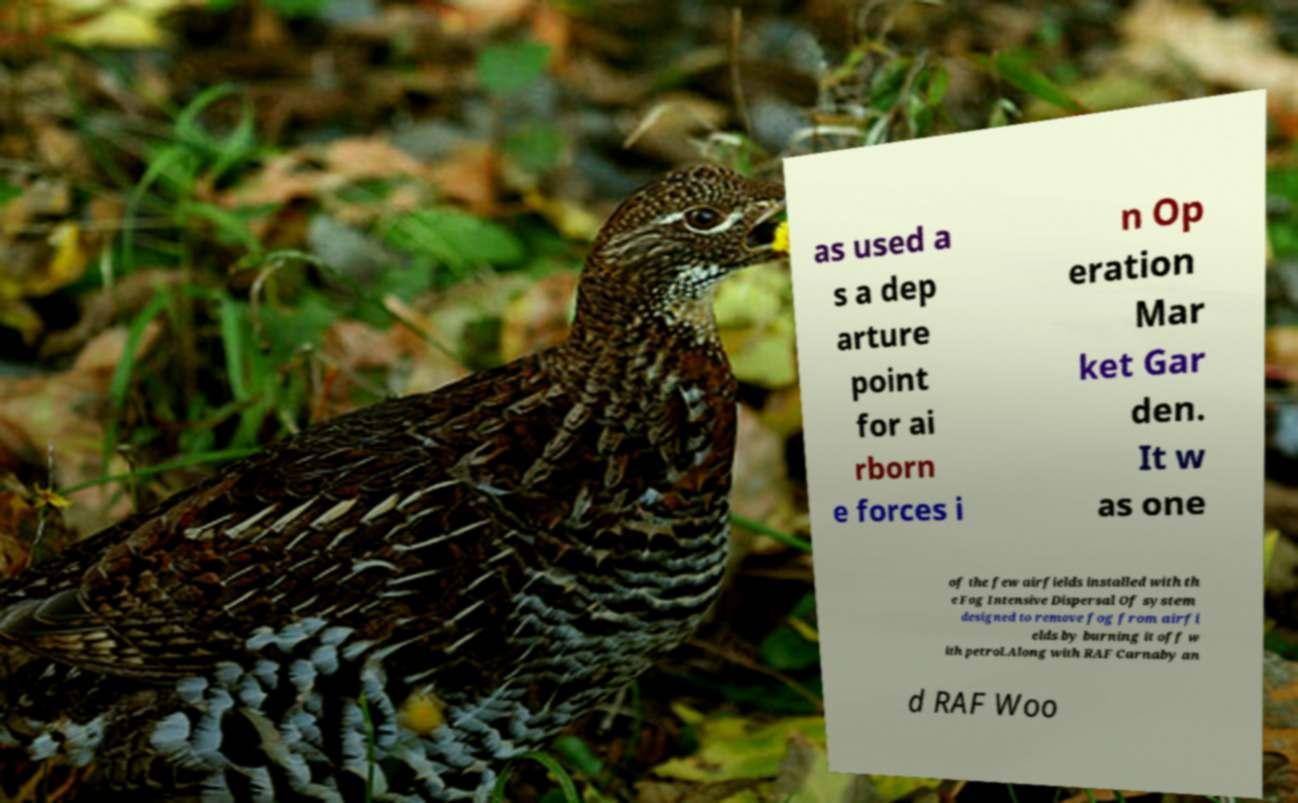There's text embedded in this image that I need extracted. Can you transcribe it verbatim? as used a s a dep arture point for ai rborn e forces i n Op eration Mar ket Gar den. It w as one of the few airfields installed with th e Fog Intensive Dispersal Of system designed to remove fog from airfi elds by burning it off w ith petrol.Along with RAF Carnaby an d RAF Woo 